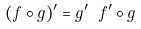Convert formula to latex. <formula><loc_0><loc_0><loc_500><loc_500>( f \circ g ) ^ { \prime } = g ^ { \prime } \ f ^ { \prime } \circ g</formula> 